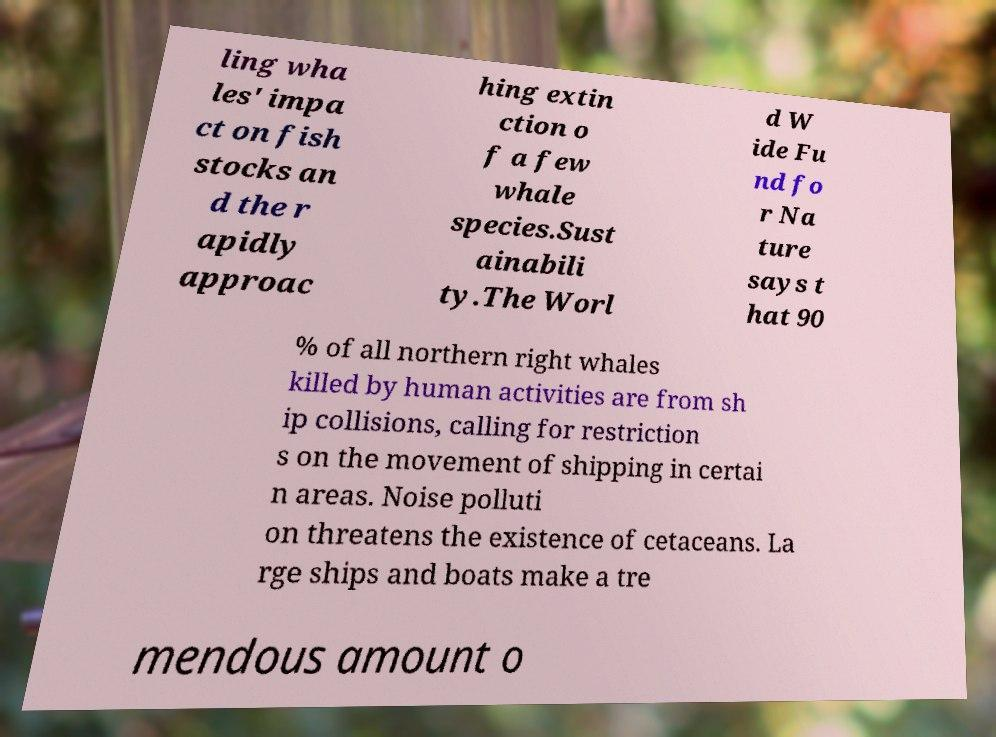For documentation purposes, I need the text within this image transcribed. Could you provide that? ling wha les' impa ct on fish stocks an d the r apidly approac hing extin ction o f a few whale species.Sust ainabili ty.The Worl d W ide Fu nd fo r Na ture says t hat 90 % of all northern right whales killed by human activities are from sh ip collisions, calling for restriction s on the movement of shipping in certai n areas. Noise polluti on threatens the existence of cetaceans. La rge ships and boats make a tre mendous amount o 